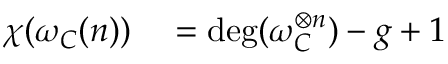<formula> <loc_0><loc_0><loc_500><loc_500>\begin{array} { r l } { \chi ( \omega _ { C } ( n ) ) } & = \deg ( \omega _ { C } ^ { \otimes n } ) - g + 1 } \end{array}</formula> 